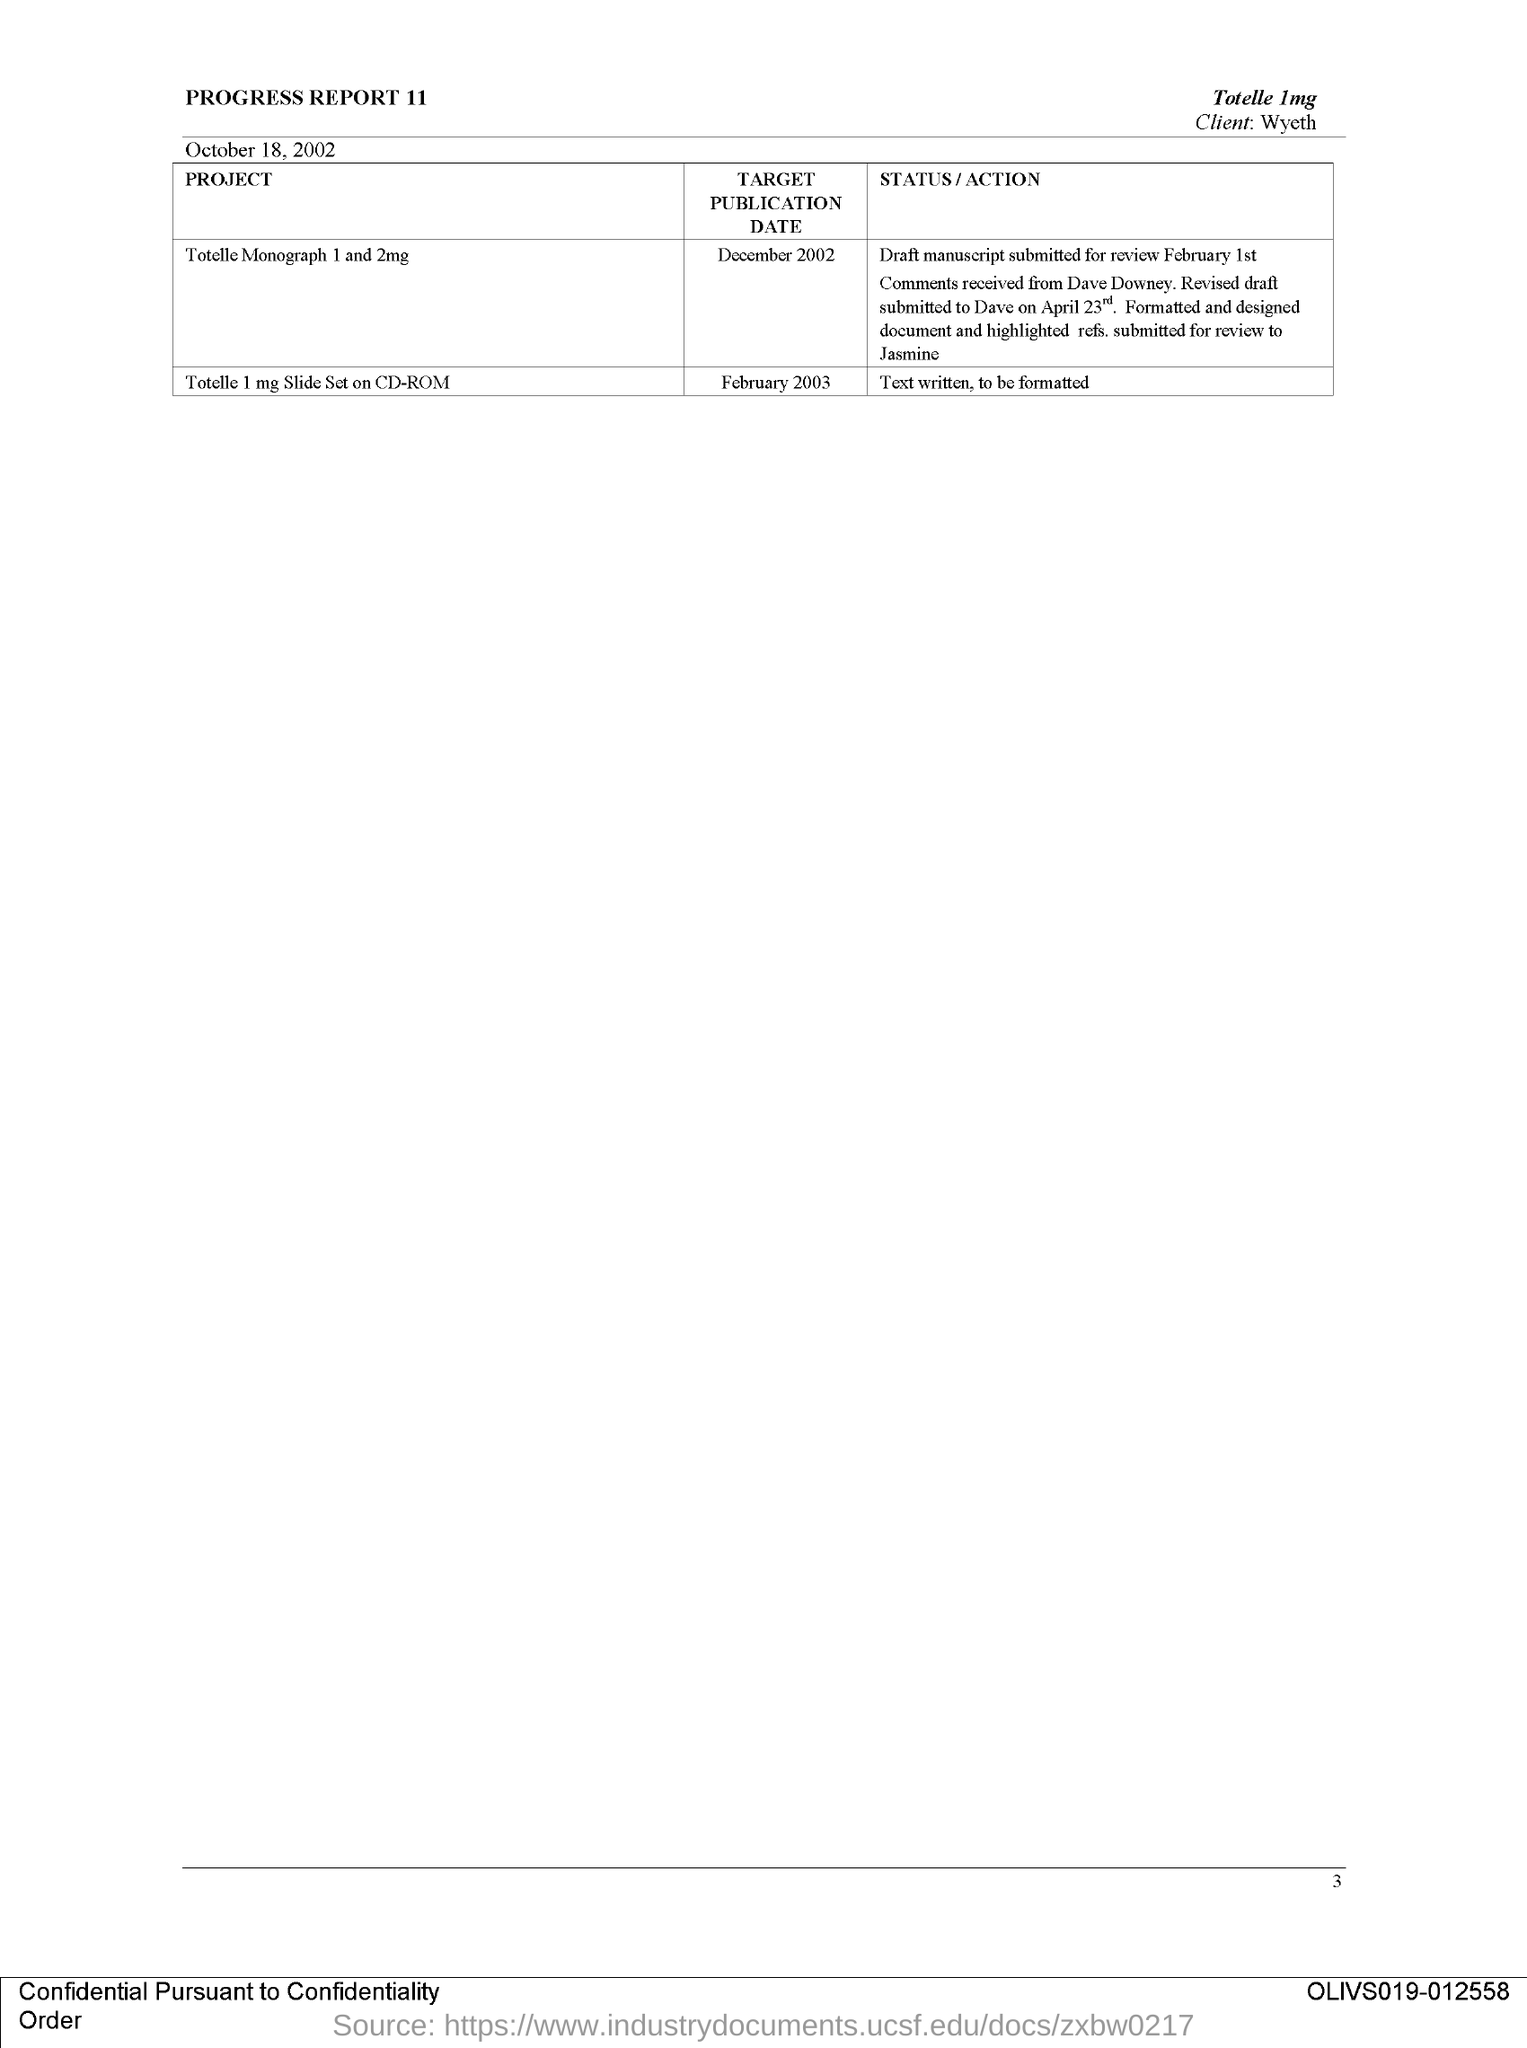Indicate a few pertinent items in this graphic. The issued date of this document is October 18, 2002. The project titled "Total 1 mg slide set on CD-ROM" is expected to be published by February 2003. This document is titled 'Progress Report 11.' The project titled "Total 1 mg slide set on CD-ROM" has a status/action mentioned of "Text written, to be formatted. The target publication date for the project titled "Totelle Monograph 1 and 2mg" is December 2002. 